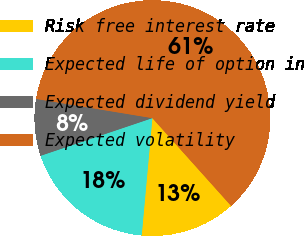Convert chart to OTSL. <chart><loc_0><loc_0><loc_500><loc_500><pie_chart><fcel>Risk free interest rate<fcel>Expected life of option in<fcel>Expected dividend yield<fcel>Expected volatility<nl><fcel>13.08%<fcel>18.38%<fcel>7.78%<fcel>60.76%<nl></chart> 